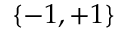Convert formula to latex. <formula><loc_0><loc_0><loc_500><loc_500>\{ - 1 , + 1 \}</formula> 